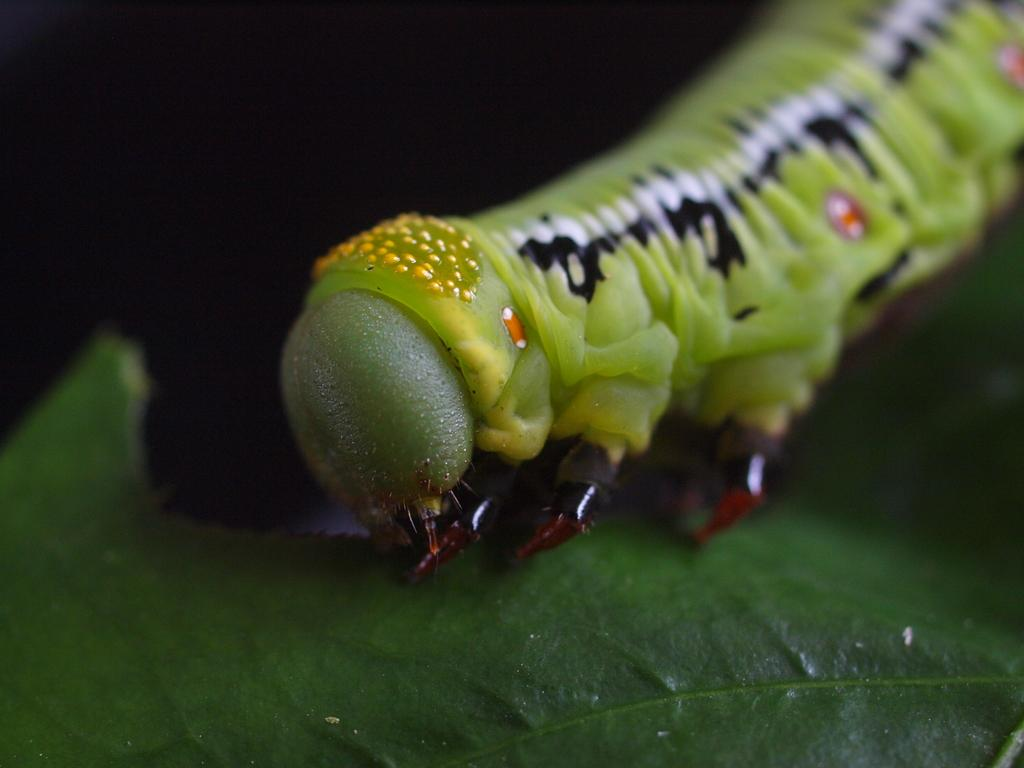What type of creature is present in the image? There is an insect in the image. Can you describe the colors of the insect? The insect has green, black, white, yellow, and orange colors. What else can be seen in the image besides the insect? There is a leaf in the image. What is the color of the leaf? The leaf is green in color. What is the background color of the image? The background of the image is black. How many birds are perched on the leaf in the image? There are no birds present in the image; it only features an insect and a leaf. 